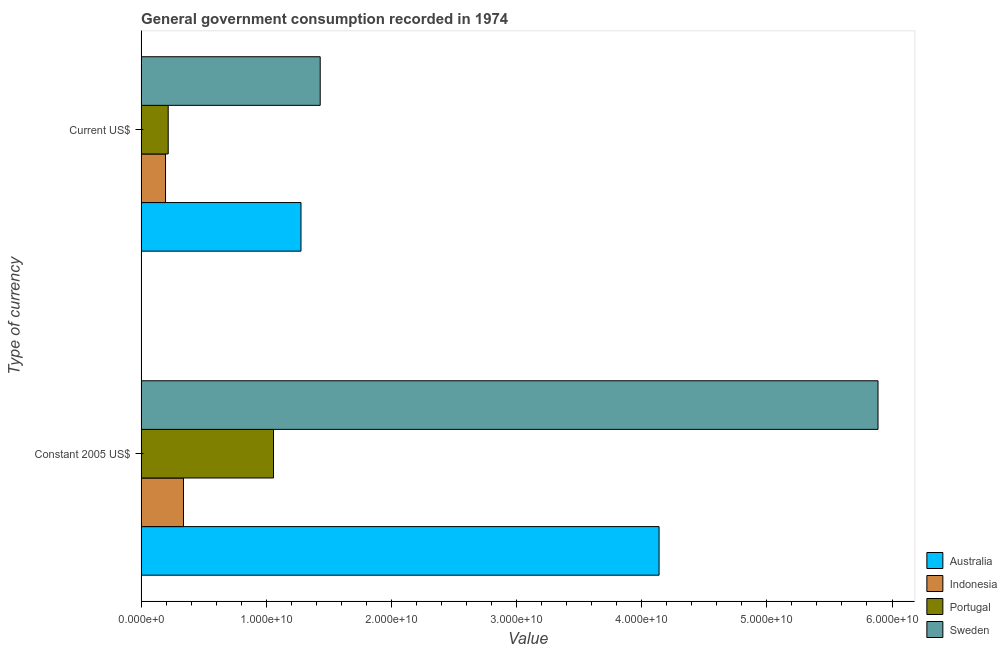Are the number of bars per tick equal to the number of legend labels?
Give a very brief answer. Yes. How many bars are there on the 1st tick from the top?
Make the answer very short. 4. How many bars are there on the 1st tick from the bottom?
Ensure brevity in your answer.  4. What is the label of the 2nd group of bars from the top?
Ensure brevity in your answer.  Constant 2005 US$. What is the value consumed in current us$ in Australia?
Keep it short and to the point. 1.28e+1. Across all countries, what is the maximum value consumed in current us$?
Offer a very short reply. 1.43e+1. Across all countries, what is the minimum value consumed in constant 2005 us$?
Make the answer very short. 3.38e+09. What is the total value consumed in current us$ in the graph?
Offer a very short reply. 3.12e+1. What is the difference between the value consumed in constant 2005 us$ in Sweden and that in Australia?
Provide a short and direct response. 1.75e+1. What is the difference between the value consumed in constant 2005 us$ in Sweden and the value consumed in current us$ in Australia?
Your answer should be very brief. 4.61e+1. What is the average value consumed in current us$ per country?
Your answer should be very brief. 7.80e+09. What is the difference between the value consumed in current us$ and value consumed in constant 2005 us$ in Portugal?
Your answer should be very brief. -8.42e+09. What is the ratio of the value consumed in current us$ in Portugal to that in Indonesia?
Make the answer very short. 1.11. In how many countries, is the value consumed in constant 2005 us$ greater than the average value consumed in constant 2005 us$ taken over all countries?
Keep it short and to the point. 2. What does the 1st bar from the top in Current US$ represents?
Offer a terse response. Sweden. What is the difference between two consecutive major ticks on the X-axis?
Your answer should be very brief. 1.00e+1. Does the graph contain any zero values?
Provide a succinct answer. No. Does the graph contain grids?
Ensure brevity in your answer.  No. Where does the legend appear in the graph?
Ensure brevity in your answer.  Bottom right. How many legend labels are there?
Keep it short and to the point. 4. How are the legend labels stacked?
Your response must be concise. Vertical. What is the title of the graph?
Ensure brevity in your answer.  General government consumption recorded in 1974. What is the label or title of the X-axis?
Provide a succinct answer. Value. What is the label or title of the Y-axis?
Offer a terse response. Type of currency. What is the Value in Australia in Constant 2005 US$?
Give a very brief answer. 4.14e+1. What is the Value in Indonesia in Constant 2005 US$?
Keep it short and to the point. 3.38e+09. What is the Value of Portugal in Constant 2005 US$?
Provide a short and direct response. 1.06e+1. What is the Value in Sweden in Constant 2005 US$?
Keep it short and to the point. 5.89e+1. What is the Value of Australia in Current US$?
Your answer should be very brief. 1.28e+1. What is the Value of Indonesia in Current US$?
Your response must be concise. 1.95e+09. What is the Value of Portugal in Current US$?
Give a very brief answer. 2.16e+09. What is the Value in Sweden in Current US$?
Provide a short and direct response. 1.43e+1. Across all Type of currency, what is the maximum Value of Australia?
Ensure brevity in your answer.  4.14e+1. Across all Type of currency, what is the maximum Value of Indonesia?
Ensure brevity in your answer.  3.38e+09. Across all Type of currency, what is the maximum Value in Portugal?
Provide a short and direct response. 1.06e+1. Across all Type of currency, what is the maximum Value in Sweden?
Offer a very short reply. 5.89e+1. Across all Type of currency, what is the minimum Value of Australia?
Give a very brief answer. 1.28e+1. Across all Type of currency, what is the minimum Value in Indonesia?
Provide a short and direct response. 1.95e+09. Across all Type of currency, what is the minimum Value of Portugal?
Ensure brevity in your answer.  2.16e+09. Across all Type of currency, what is the minimum Value in Sweden?
Provide a succinct answer. 1.43e+1. What is the total Value in Australia in the graph?
Give a very brief answer. 5.42e+1. What is the total Value in Indonesia in the graph?
Keep it short and to the point. 5.33e+09. What is the total Value in Portugal in the graph?
Offer a very short reply. 1.27e+1. What is the total Value of Sweden in the graph?
Your response must be concise. 7.32e+1. What is the difference between the Value in Australia in Constant 2005 US$ and that in Current US$?
Offer a terse response. 2.86e+1. What is the difference between the Value of Indonesia in Constant 2005 US$ and that in Current US$?
Your response must be concise. 1.43e+09. What is the difference between the Value of Portugal in Constant 2005 US$ and that in Current US$?
Ensure brevity in your answer.  8.42e+09. What is the difference between the Value of Sweden in Constant 2005 US$ and that in Current US$?
Your answer should be compact. 4.46e+1. What is the difference between the Value of Australia in Constant 2005 US$ and the Value of Indonesia in Current US$?
Your answer should be compact. 3.94e+1. What is the difference between the Value in Australia in Constant 2005 US$ and the Value in Portugal in Current US$?
Give a very brief answer. 3.92e+1. What is the difference between the Value of Australia in Constant 2005 US$ and the Value of Sweden in Current US$?
Provide a succinct answer. 2.71e+1. What is the difference between the Value in Indonesia in Constant 2005 US$ and the Value in Portugal in Current US$?
Offer a terse response. 1.22e+09. What is the difference between the Value of Indonesia in Constant 2005 US$ and the Value of Sweden in Current US$?
Provide a short and direct response. -1.09e+1. What is the difference between the Value in Portugal in Constant 2005 US$ and the Value in Sweden in Current US$?
Your answer should be compact. -3.73e+09. What is the average Value in Australia per Type of currency?
Your response must be concise. 2.71e+1. What is the average Value in Indonesia per Type of currency?
Provide a short and direct response. 2.67e+09. What is the average Value of Portugal per Type of currency?
Make the answer very short. 6.37e+09. What is the average Value of Sweden per Type of currency?
Offer a terse response. 3.66e+1. What is the difference between the Value in Australia and Value in Indonesia in Constant 2005 US$?
Keep it short and to the point. 3.80e+1. What is the difference between the Value in Australia and Value in Portugal in Constant 2005 US$?
Offer a very short reply. 3.08e+1. What is the difference between the Value of Australia and Value of Sweden in Constant 2005 US$?
Your answer should be compact. -1.75e+1. What is the difference between the Value in Indonesia and Value in Portugal in Constant 2005 US$?
Offer a terse response. -7.20e+09. What is the difference between the Value of Indonesia and Value of Sweden in Constant 2005 US$?
Provide a short and direct response. -5.55e+1. What is the difference between the Value of Portugal and Value of Sweden in Constant 2005 US$?
Offer a very short reply. -4.83e+1. What is the difference between the Value of Australia and Value of Indonesia in Current US$?
Ensure brevity in your answer.  1.08e+1. What is the difference between the Value in Australia and Value in Portugal in Current US$?
Ensure brevity in your answer.  1.06e+1. What is the difference between the Value of Australia and Value of Sweden in Current US$?
Ensure brevity in your answer.  -1.54e+09. What is the difference between the Value in Indonesia and Value in Portugal in Current US$?
Ensure brevity in your answer.  -2.14e+08. What is the difference between the Value of Indonesia and Value of Sweden in Current US$?
Give a very brief answer. -1.24e+1. What is the difference between the Value of Portugal and Value of Sweden in Current US$?
Keep it short and to the point. -1.21e+1. What is the ratio of the Value in Australia in Constant 2005 US$ to that in Current US$?
Ensure brevity in your answer.  3.24. What is the ratio of the Value in Indonesia in Constant 2005 US$ to that in Current US$?
Offer a very short reply. 1.74. What is the ratio of the Value of Portugal in Constant 2005 US$ to that in Current US$?
Offer a very short reply. 4.89. What is the ratio of the Value in Sweden in Constant 2005 US$ to that in Current US$?
Offer a terse response. 4.12. What is the difference between the highest and the second highest Value of Australia?
Give a very brief answer. 2.86e+1. What is the difference between the highest and the second highest Value of Indonesia?
Provide a succinct answer. 1.43e+09. What is the difference between the highest and the second highest Value of Portugal?
Keep it short and to the point. 8.42e+09. What is the difference between the highest and the second highest Value of Sweden?
Provide a succinct answer. 4.46e+1. What is the difference between the highest and the lowest Value in Australia?
Offer a very short reply. 2.86e+1. What is the difference between the highest and the lowest Value in Indonesia?
Your answer should be very brief. 1.43e+09. What is the difference between the highest and the lowest Value of Portugal?
Offer a terse response. 8.42e+09. What is the difference between the highest and the lowest Value in Sweden?
Provide a succinct answer. 4.46e+1. 